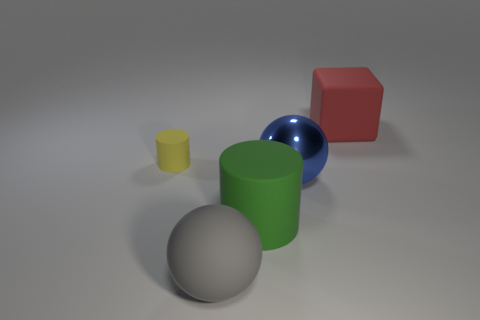The thing behind the matte object on the left side of the sphere that is left of the big blue object is what color?
Provide a succinct answer. Red. Do the big blue thing and the gray object have the same material?
Offer a terse response. No. Do the shiny thing and the big gray thing have the same shape?
Your response must be concise. Yes. Are there an equal number of small yellow cylinders that are behind the small thing and green cylinders that are on the left side of the blue metallic object?
Your response must be concise. No. There is a ball that is the same material as the big cube; what is its color?
Your answer should be very brief. Gray. How many small yellow objects have the same material as the gray object?
Offer a very short reply. 1. Does the rubber thing that is behind the tiny matte object have the same color as the large metal thing?
Give a very brief answer. No. What number of other tiny yellow rubber things have the same shape as the yellow thing?
Give a very brief answer. 0. Is the number of yellow objects that are left of the yellow matte thing the same as the number of large purple rubber balls?
Offer a very short reply. Yes. The ball that is the same size as the gray rubber object is what color?
Offer a very short reply. Blue. 